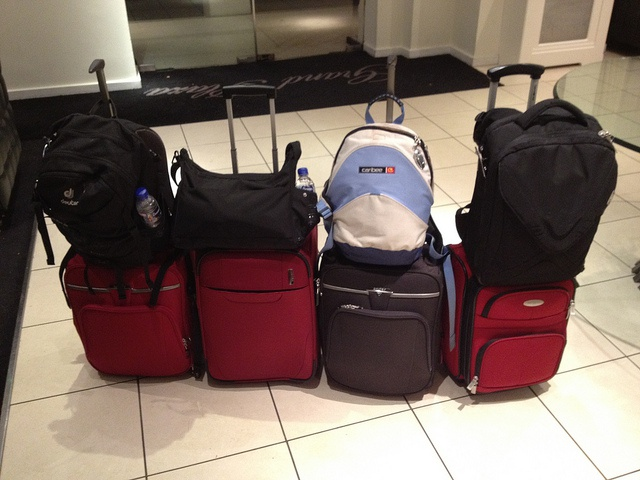Describe the objects in this image and their specific colors. I can see backpack in gray, black, and tan tones, suitcase in gray, black, and tan tones, backpack in gray, black, and navy tones, suitcase in gray and black tones, and suitcase in gray, maroon, black, and brown tones in this image. 